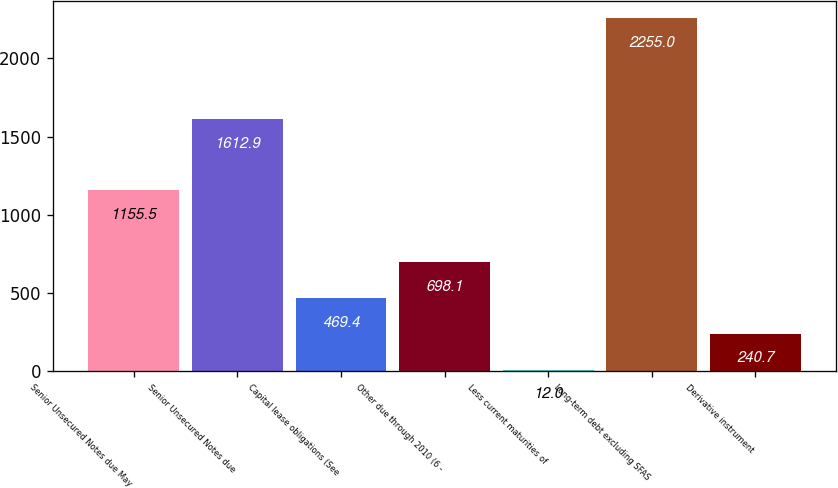<chart> <loc_0><loc_0><loc_500><loc_500><bar_chart><fcel>Senior Unsecured Notes due May<fcel>Senior Unsecured Notes due<fcel>Capital lease obligations (See<fcel>Other due through 2010 (6 -<fcel>Less current maturities of<fcel>Long-term debt excluding SFAS<fcel>Derivative instrument<nl><fcel>1155.5<fcel>1612.9<fcel>469.4<fcel>698.1<fcel>12<fcel>2255<fcel>240.7<nl></chart> 